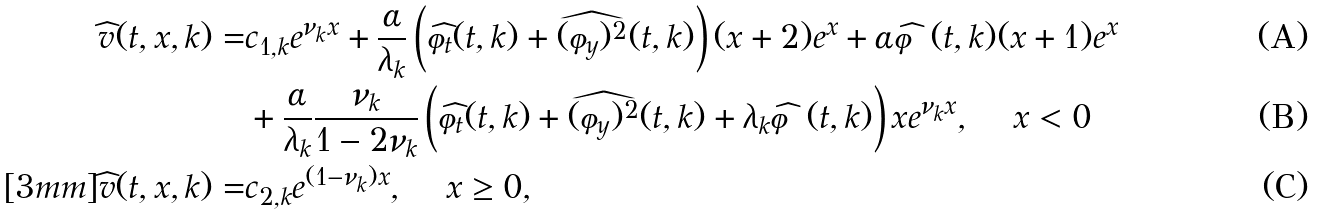<formula> <loc_0><loc_0><loc_500><loc_500>\widehat { v } ( t , x , k ) = & c _ { 1 , k } e ^ { \nu _ { k } x } + \frac { \alpha } { \lambda _ { k } } \left ( \widehat { \varphi } _ { t } ( t , k ) + \widehat { ( \varphi _ { y } ) ^ { 2 } } ( t , k ) \right ) ( x + 2 ) e ^ { x } + \alpha \widehat { \varphi } ( t , k ) ( x + 1 ) e ^ { x } \\ & + \frac { \alpha } { \lambda _ { k } } \frac { \nu _ { k } } { 1 - 2 \nu _ { k } } \left ( \widehat { \varphi } _ { t } ( t , k ) + \widehat { ( \varphi _ { y } ) ^ { 2 } } ( t , k ) + \lambda _ { k } \widehat { \varphi } ( t , k ) \right ) x e ^ { \nu _ { k } x } , \quad \, x < 0 \\ [ 3 m m ] \widehat { v } ( t , x , k ) = & c _ { 2 , k } e ^ { ( 1 - \nu _ { k } ) x } , \quad \, x \geq 0 ,</formula> 